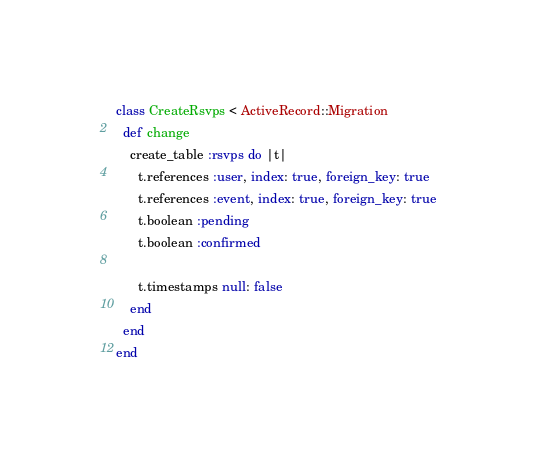Convert code to text. <code><loc_0><loc_0><loc_500><loc_500><_Ruby_>class CreateRsvps < ActiveRecord::Migration
  def change
    create_table :rsvps do |t|
      t.references :user, index: true, foreign_key: true
      t.references :event, index: true, foreign_key: true
      t.boolean :pending
      t.boolean :confirmed

      t.timestamps null: false
    end
  end
end
</code> 